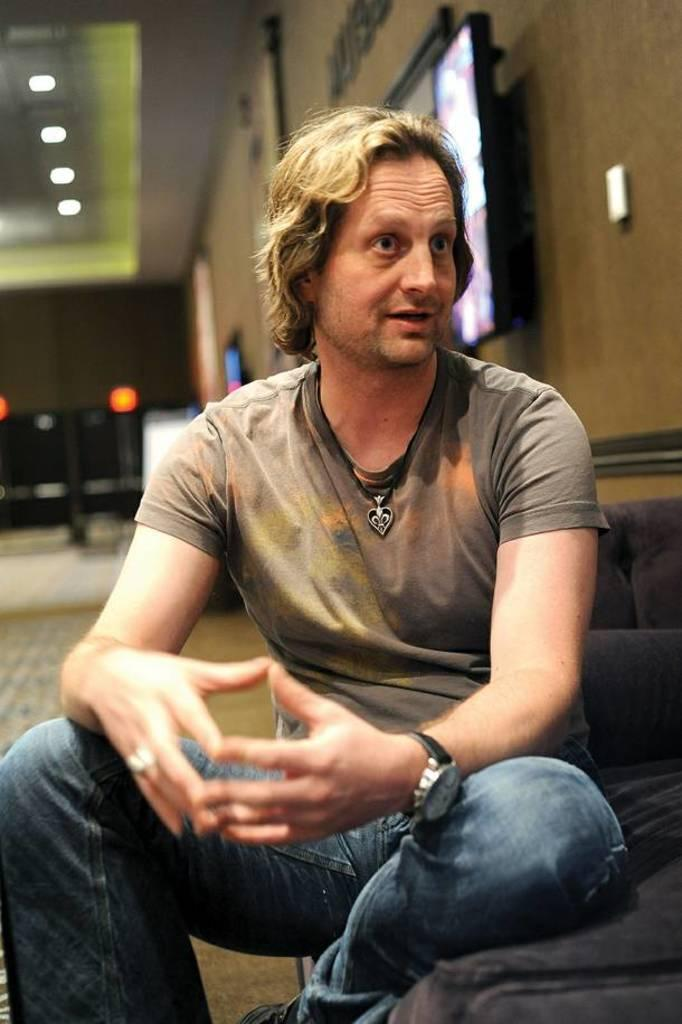What is the man in the image doing? The man is sitting in the image. What can be seen in the background of the image? There are lights, the floor, a wall, and screens visible in the background of the image. How does the man plan to join the crowd in the image? There is no crowd present in the image, so the man cannot join a crowd. 